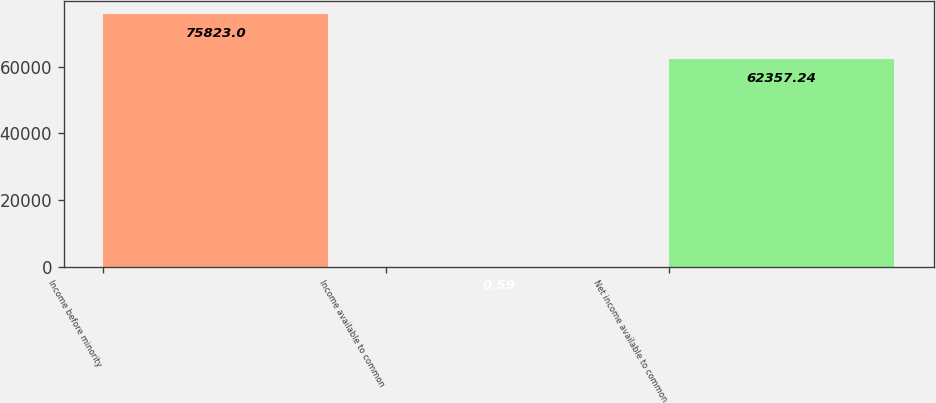Convert chart to OTSL. <chart><loc_0><loc_0><loc_500><loc_500><bar_chart><fcel>Income before minority<fcel>Income available to common<fcel>Net income available to common<nl><fcel>75823<fcel>0.59<fcel>62357.2<nl></chart> 